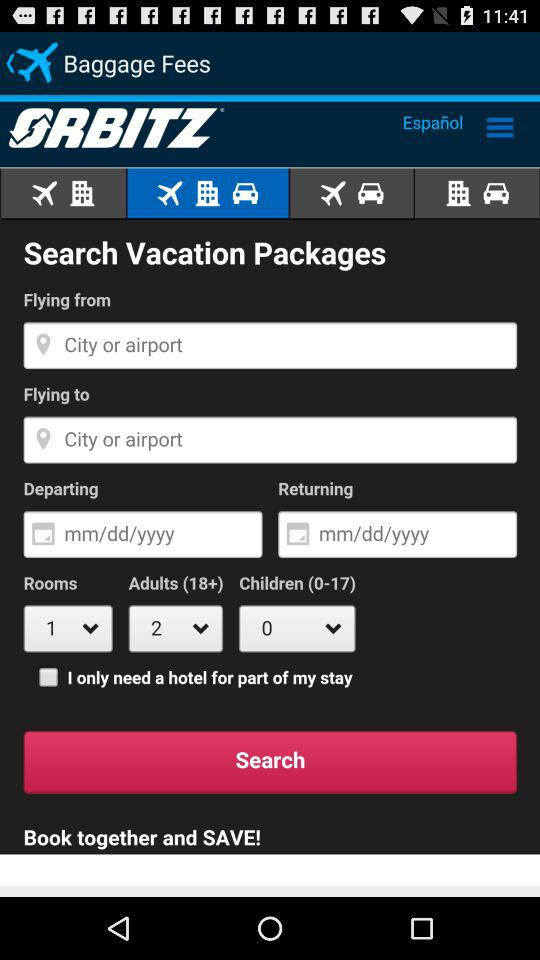What is the application name? The application name is "Orbitz Hotels & Flights". 